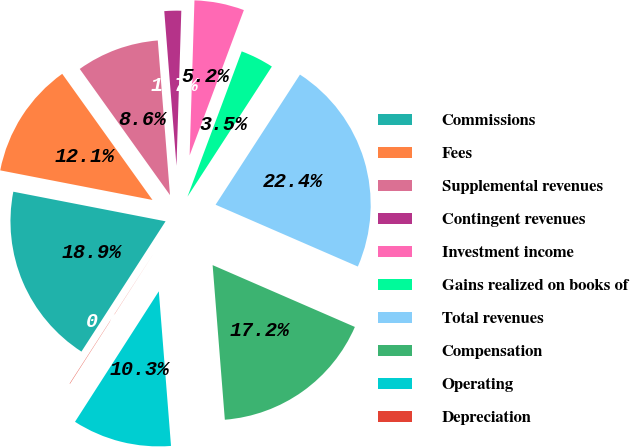<chart> <loc_0><loc_0><loc_500><loc_500><pie_chart><fcel>Commissions<fcel>Fees<fcel>Supplemental revenues<fcel>Contingent revenues<fcel>Investment income<fcel>Gains realized on books of<fcel>Total revenues<fcel>Compensation<fcel>Operating<fcel>Depreciation<nl><fcel>18.93%<fcel>12.06%<fcel>8.63%<fcel>1.75%<fcel>5.19%<fcel>3.47%<fcel>22.37%<fcel>17.22%<fcel>10.34%<fcel>0.04%<nl></chart> 